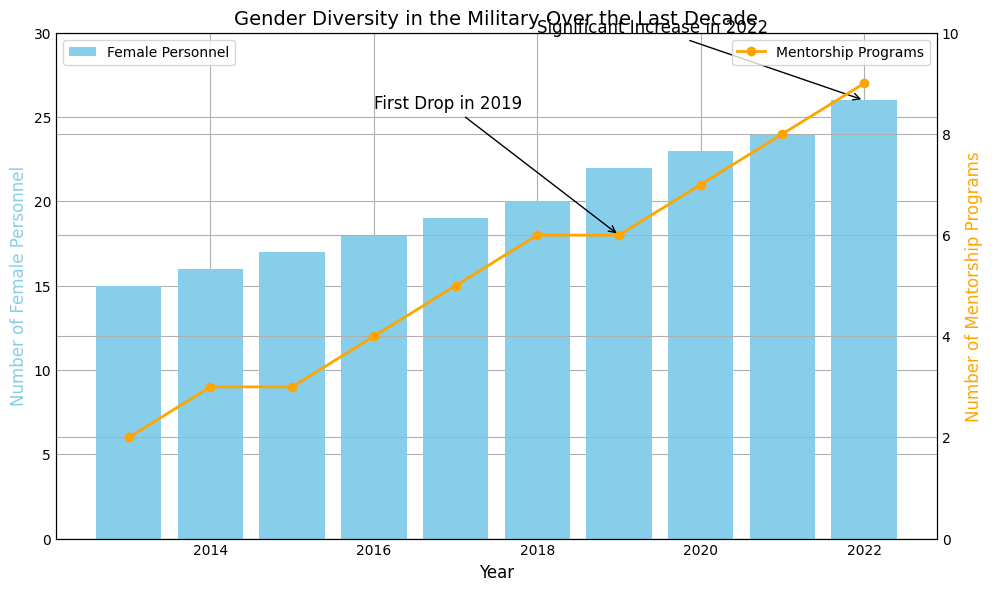What's the number of Female Personnel in 2022? To find this, look at the bar corresponding to the year 2022 on the plot. Based on the height of the bar, it indicates 26.
Answer: 26 By how many did the number of Mentorship Programs increase from 2013 to 2017? Look at the line chart and read the values for 2013 and 2017. In 2013, there were 2 mentorship programs, and in 2017, there were 5. The increase is 5 - 2 = 3 programs.
Answer: 3 Which year experienced the highest increase in Female Personnel compared to the previous year? By observing the heights of the bars, determine the differences year over year. The highest increase is from 2021 (24) to 2022 (26), with an increase of 2.
Answer: 2022 Is there any year when the number of Mentorship Programs decreased? Referring to the line plot, there is a slight drop in mentorship programs from 2019 (6) to 2020 (6). However, it wasn't a drop since it remained the same; thus, the answer is no.
Answer: No How did the number of Female Personnel change between 2016 and 2022? Look at the bar heights for 2016 and 2022. In 2016, it was 18, and in 2022, it was 26. The change is 26 - 18 = 8.
Answer: 8 Compare the trend of Female Personnel to Mentorship Programs over the decade. Which grew more significantly? Observe both the bar and line plots. Both increase, but Mentorship Programs started at 2 and reached 9, a change of 7. Female Personnel started at 15 and reached 26, a change of 11. Although the numerical change is greater for Female Personnel, the growth rate percentage-wise appears more significant for Mentorship Programs.
Answer: Mentorship Programs What visual element indicates the importance of the year 2022? The annotation "Significant Increase in 2022" with an arrow pointing at the 2022 bar indicates it. The bar height for Female Personnel is the highest, highlighting its significant value.
Answer: Annotation and bar height What is the average number of Female Personnel from 2013 to 2022? Calculate the average by summing the Female Personnel values and then dividing them by the number of years. (15+16+17+18+19+20+22+23+24+26)/10 = 20.
Answer: 20 Which year saw the introduction of more than 5 Mentorship Programs for the first time? The line chart shows that it happened in 2018 when the count increased to 6.
Answer: 2018 Identify the year with the first drop annotation and its corresponding value change. The annotation "First Drop in 2019" points to 2019 for Mentorship Programs. The value remained 6 from 2018 to 2019, and thus, the value change is 0.
Answer: 2019, 0 